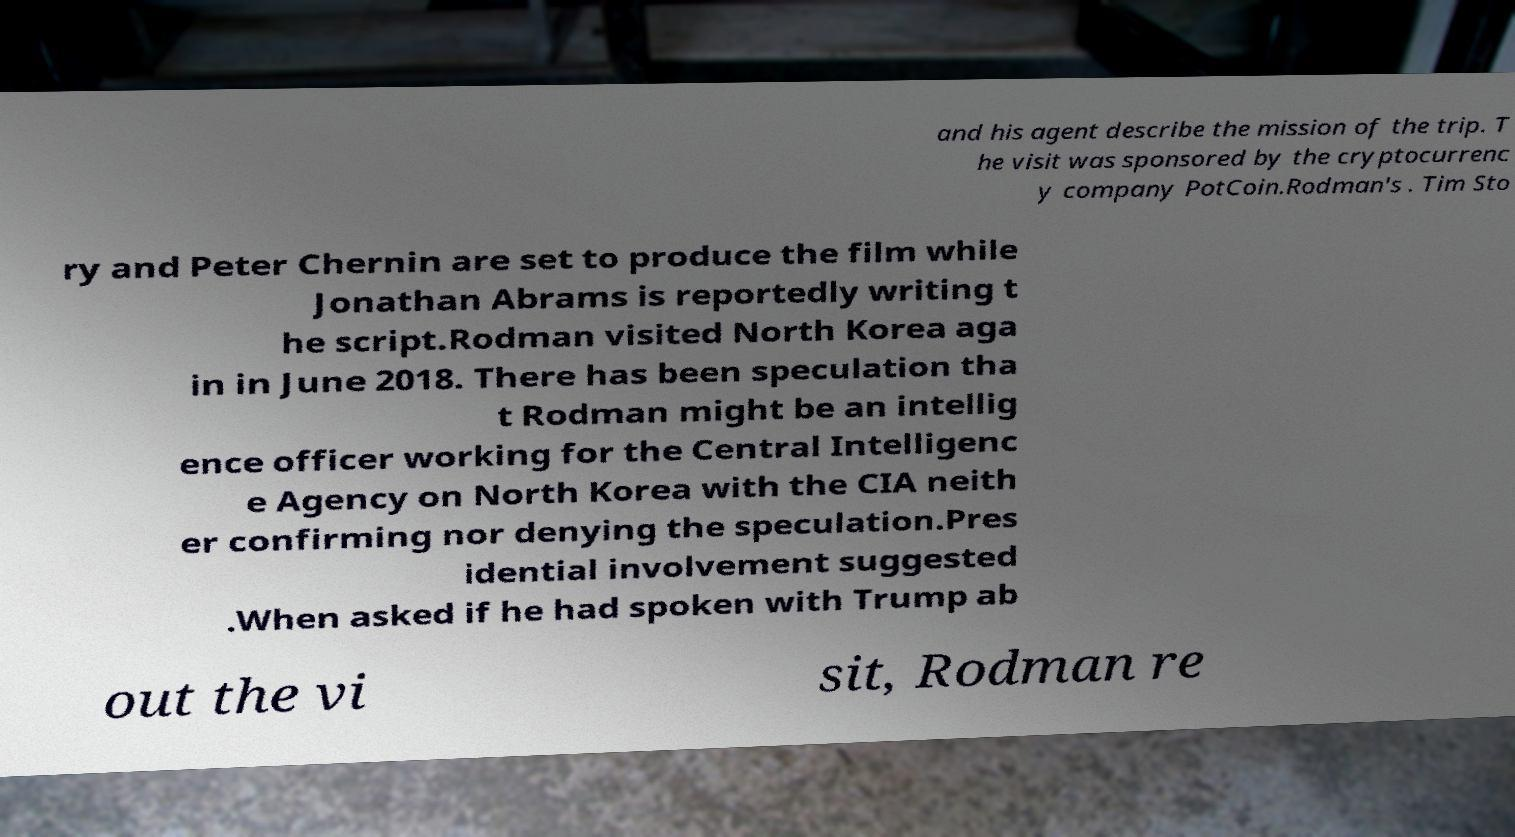Please read and relay the text visible in this image. What does it say? and his agent describe the mission of the trip. T he visit was sponsored by the cryptocurrenc y company PotCoin.Rodman's . Tim Sto ry and Peter Chernin are set to produce the film while Jonathan Abrams is reportedly writing t he script.Rodman visited North Korea aga in in June 2018. There has been speculation tha t Rodman might be an intellig ence officer working for the Central Intelligenc e Agency on North Korea with the CIA neith er confirming nor denying the speculation.Pres idential involvement suggested .When asked if he had spoken with Trump ab out the vi sit, Rodman re 